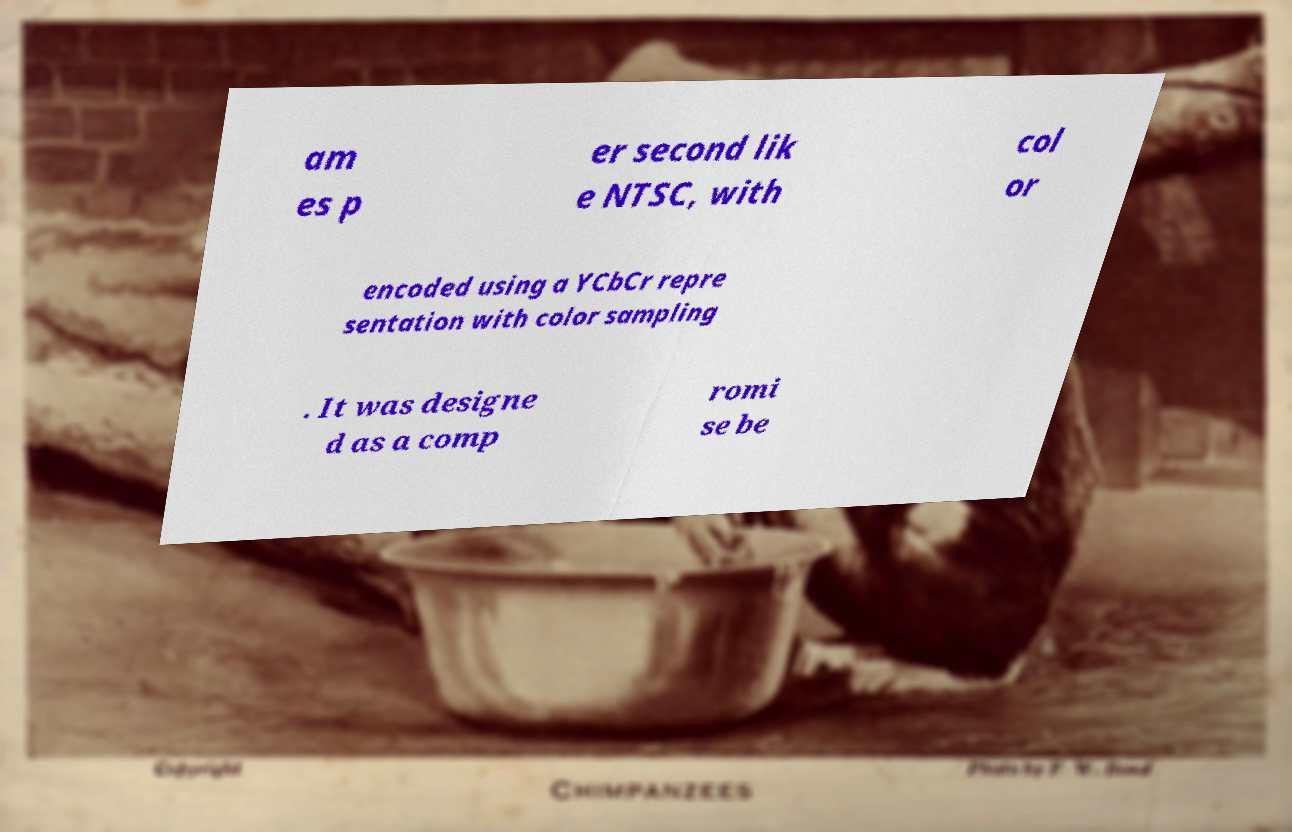Could you assist in decoding the text presented in this image and type it out clearly? am es p er second lik e NTSC, with col or encoded using a YCbCr repre sentation with color sampling . It was designe d as a comp romi se be 